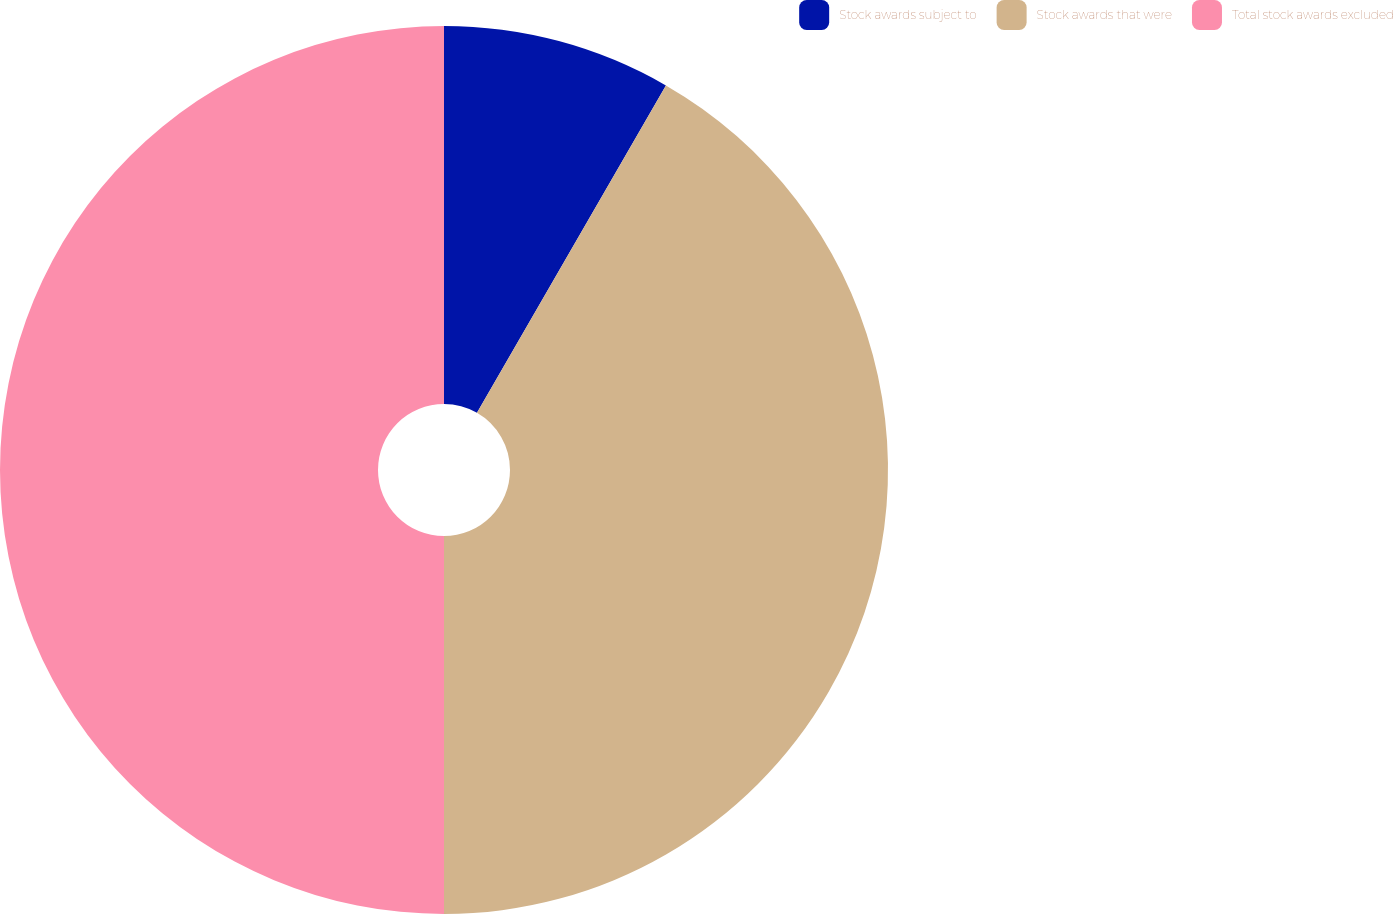Convert chart to OTSL. <chart><loc_0><loc_0><loc_500><loc_500><pie_chart><fcel>Stock awards subject to<fcel>Stock awards that were<fcel>Total stock awards excluded<nl><fcel>8.33%<fcel>41.67%<fcel>50.0%<nl></chart> 